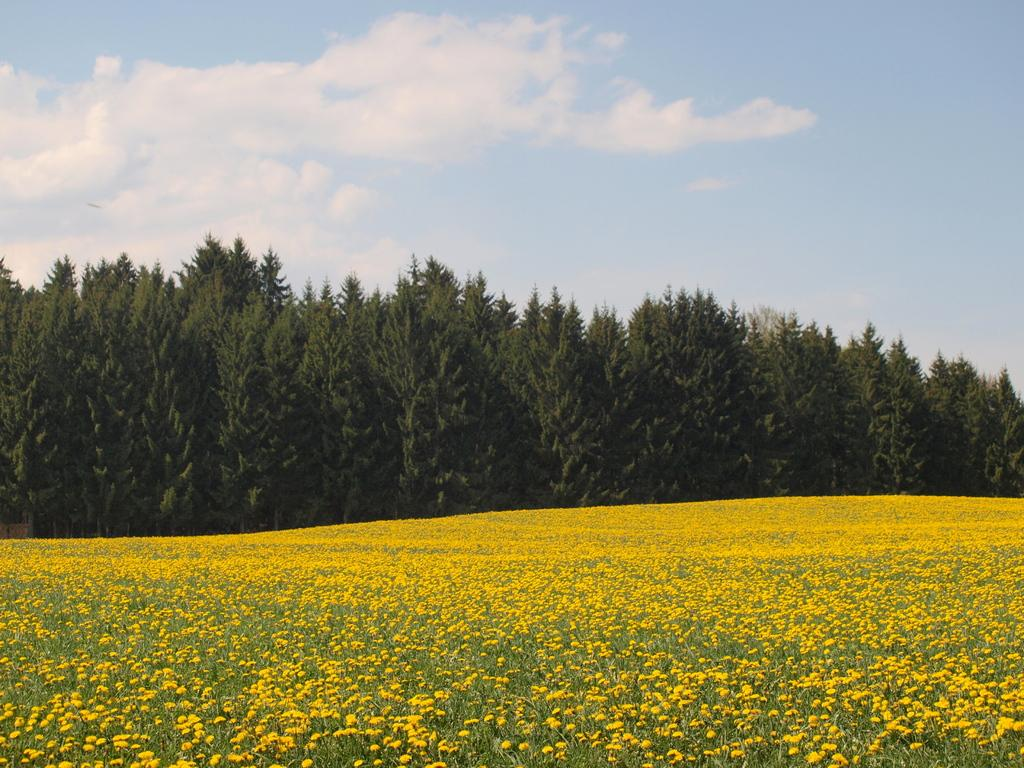What type of flowers can be seen in the foreground of the image? There are yellow flowers in the foreground of the image. What else is present in the foreground of the image besides the flowers? There are plants in the foreground of the image. What can be seen in the middle of the image? There are trees in the middle of the image. What is visible at the top of the image? The sky is visible at the top of the image. Can you describe the sky in the image? There is a cloud in the sky. How many visitors can be seen in the image? There are no visitors present in the image. What type of fog can be seen in the image? There is no fog present in the image; it features a clear sky with a cloud. 